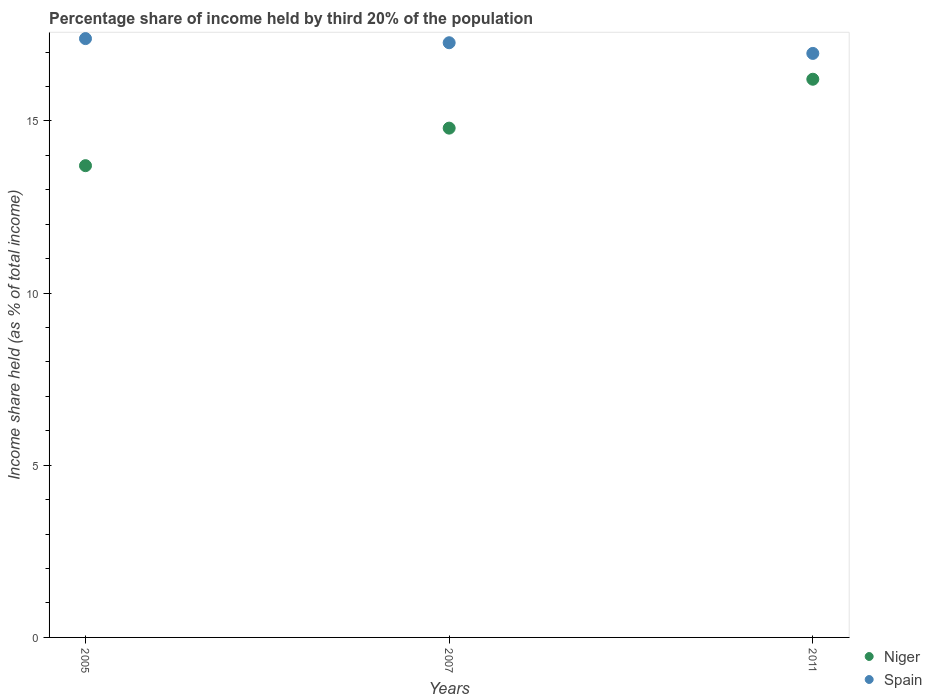How many different coloured dotlines are there?
Ensure brevity in your answer.  2. Is the number of dotlines equal to the number of legend labels?
Make the answer very short. Yes. What is the share of income held by third 20% of the population in Spain in 2007?
Provide a succinct answer. 17.27. Across all years, what is the maximum share of income held by third 20% of the population in Spain?
Your answer should be compact. 17.39. In which year was the share of income held by third 20% of the population in Niger minimum?
Keep it short and to the point. 2005. What is the total share of income held by third 20% of the population in Spain in the graph?
Ensure brevity in your answer.  51.62. What is the difference between the share of income held by third 20% of the population in Spain in 2005 and that in 2007?
Provide a short and direct response. 0.12. What is the difference between the share of income held by third 20% of the population in Niger in 2011 and the share of income held by third 20% of the population in Spain in 2007?
Your answer should be very brief. -1.06. In how many years, is the share of income held by third 20% of the population in Niger greater than 16 %?
Ensure brevity in your answer.  1. What is the ratio of the share of income held by third 20% of the population in Niger in 2005 to that in 2011?
Offer a terse response. 0.85. Is the difference between the share of income held by third 20% of the population in Spain in 2007 and 2011 greater than the difference between the share of income held by third 20% of the population in Niger in 2007 and 2011?
Make the answer very short. Yes. What is the difference between the highest and the second highest share of income held by third 20% of the population in Spain?
Your answer should be compact. 0.12. What is the difference between the highest and the lowest share of income held by third 20% of the population in Spain?
Keep it short and to the point. 0.43. Is the sum of the share of income held by third 20% of the population in Niger in 2007 and 2011 greater than the maximum share of income held by third 20% of the population in Spain across all years?
Provide a succinct answer. Yes. Does the share of income held by third 20% of the population in Spain monotonically increase over the years?
Ensure brevity in your answer.  No. Is the share of income held by third 20% of the population in Niger strictly greater than the share of income held by third 20% of the population in Spain over the years?
Ensure brevity in your answer.  No. Are the values on the major ticks of Y-axis written in scientific E-notation?
Provide a short and direct response. No. Does the graph contain any zero values?
Keep it short and to the point. No. Does the graph contain grids?
Offer a terse response. No. How many legend labels are there?
Make the answer very short. 2. What is the title of the graph?
Provide a short and direct response. Percentage share of income held by third 20% of the population. What is the label or title of the Y-axis?
Provide a succinct answer. Income share held (as % of total income). What is the Income share held (as % of total income) of Spain in 2005?
Your response must be concise. 17.39. What is the Income share held (as % of total income) of Niger in 2007?
Provide a short and direct response. 14.79. What is the Income share held (as % of total income) of Spain in 2007?
Make the answer very short. 17.27. What is the Income share held (as % of total income) in Niger in 2011?
Your answer should be very brief. 16.21. What is the Income share held (as % of total income) in Spain in 2011?
Ensure brevity in your answer.  16.96. Across all years, what is the maximum Income share held (as % of total income) of Niger?
Your answer should be very brief. 16.21. Across all years, what is the maximum Income share held (as % of total income) of Spain?
Ensure brevity in your answer.  17.39. Across all years, what is the minimum Income share held (as % of total income) in Spain?
Your response must be concise. 16.96. What is the total Income share held (as % of total income) in Niger in the graph?
Keep it short and to the point. 44.7. What is the total Income share held (as % of total income) of Spain in the graph?
Your answer should be very brief. 51.62. What is the difference between the Income share held (as % of total income) of Niger in 2005 and that in 2007?
Provide a succinct answer. -1.09. What is the difference between the Income share held (as % of total income) of Spain in 2005 and that in 2007?
Give a very brief answer. 0.12. What is the difference between the Income share held (as % of total income) in Niger in 2005 and that in 2011?
Your answer should be very brief. -2.51. What is the difference between the Income share held (as % of total income) in Spain in 2005 and that in 2011?
Give a very brief answer. 0.43. What is the difference between the Income share held (as % of total income) in Niger in 2007 and that in 2011?
Provide a short and direct response. -1.42. What is the difference between the Income share held (as % of total income) in Spain in 2007 and that in 2011?
Provide a short and direct response. 0.31. What is the difference between the Income share held (as % of total income) of Niger in 2005 and the Income share held (as % of total income) of Spain in 2007?
Offer a very short reply. -3.57. What is the difference between the Income share held (as % of total income) in Niger in 2005 and the Income share held (as % of total income) in Spain in 2011?
Provide a short and direct response. -3.26. What is the difference between the Income share held (as % of total income) of Niger in 2007 and the Income share held (as % of total income) of Spain in 2011?
Your answer should be very brief. -2.17. What is the average Income share held (as % of total income) of Spain per year?
Provide a succinct answer. 17.21. In the year 2005, what is the difference between the Income share held (as % of total income) in Niger and Income share held (as % of total income) in Spain?
Your response must be concise. -3.69. In the year 2007, what is the difference between the Income share held (as % of total income) in Niger and Income share held (as % of total income) in Spain?
Offer a very short reply. -2.48. In the year 2011, what is the difference between the Income share held (as % of total income) in Niger and Income share held (as % of total income) in Spain?
Offer a terse response. -0.75. What is the ratio of the Income share held (as % of total income) in Niger in 2005 to that in 2007?
Give a very brief answer. 0.93. What is the ratio of the Income share held (as % of total income) of Niger in 2005 to that in 2011?
Give a very brief answer. 0.85. What is the ratio of the Income share held (as % of total income) in Spain in 2005 to that in 2011?
Offer a very short reply. 1.03. What is the ratio of the Income share held (as % of total income) in Niger in 2007 to that in 2011?
Your answer should be compact. 0.91. What is the ratio of the Income share held (as % of total income) in Spain in 2007 to that in 2011?
Your answer should be very brief. 1.02. What is the difference between the highest and the second highest Income share held (as % of total income) in Niger?
Give a very brief answer. 1.42. What is the difference between the highest and the second highest Income share held (as % of total income) of Spain?
Make the answer very short. 0.12. What is the difference between the highest and the lowest Income share held (as % of total income) in Niger?
Your answer should be compact. 2.51. What is the difference between the highest and the lowest Income share held (as % of total income) in Spain?
Offer a very short reply. 0.43. 